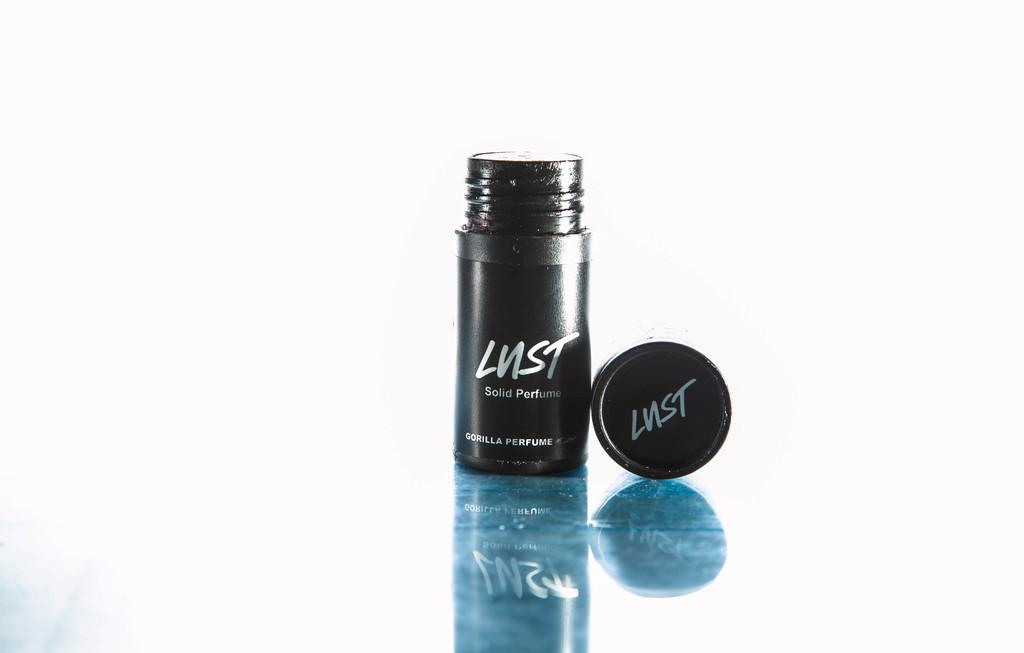What is the main object in the image? There is a perfume in the image. Where is the perfume located? The perfume is placed on a table. What is the status of the perfume's cap? The cap of the perfume is open. What color is the perfume bottle? The bottle of the perfume is black in color. What type of wool is being used to make the oranges in the image? There are no oranges or wool present in the image; it features a perfume with a black bottle and an open cap. 